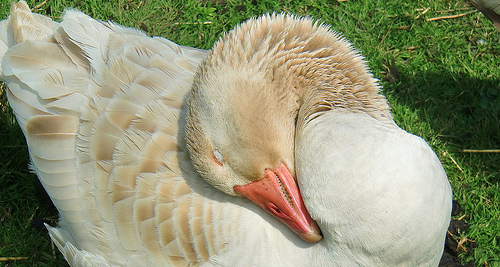<image>
Is the beak on the duck? Yes. Looking at the image, I can see the beak is positioned on top of the duck, with the duck providing support. 